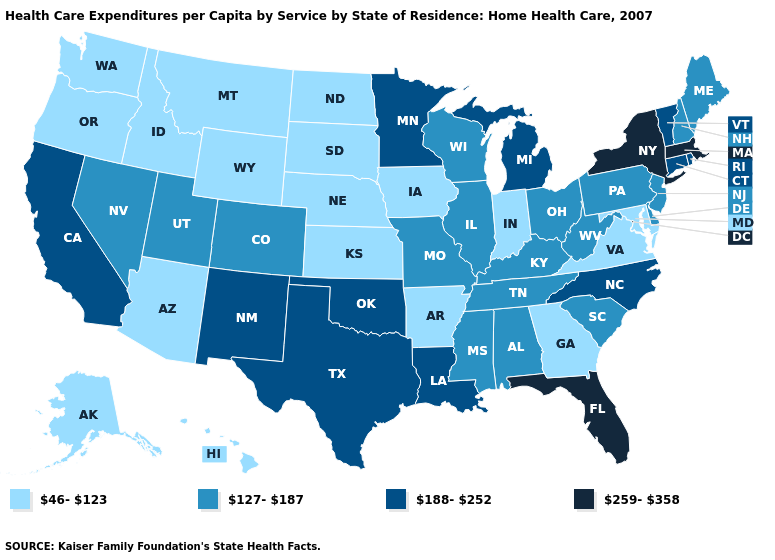Which states have the highest value in the USA?
Give a very brief answer. Florida, Massachusetts, New York. Does Louisiana have a higher value than West Virginia?
Answer briefly. Yes. How many symbols are there in the legend?
Concise answer only. 4. What is the lowest value in the Northeast?
Be succinct. 127-187. Is the legend a continuous bar?
Write a very short answer. No. What is the value of Illinois?
Quick response, please. 127-187. What is the value of Minnesota?
Keep it brief. 188-252. Does Kentucky have a lower value than Oklahoma?
Short answer required. Yes. Name the states that have a value in the range 46-123?
Answer briefly. Alaska, Arizona, Arkansas, Georgia, Hawaii, Idaho, Indiana, Iowa, Kansas, Maryland, Montana, Nebraska, North Dakota, Oregon, South Dakota, Virginia, Washington, Wyoming. What is the value of Virginia?
Be succinct. 46-123. What is the value of Maryland?
Be succinct. 46-123. What is the value of Pennsylvania?
Concise answer only. 127-187. What is the highest value in states that border Delaware?
Concise answer only. 127-187. Which states have the lowest value in the USA?
Concise answer only. Alaska, Arizona, Arkansas, Georgia, Hawaii, Idaho, Indiana, Iowa, Kansas, Maryland, Montana, Nebraska, North Dakota, Oregon, South Dakota, Virginia, Washington, Wyoming. Which states have the highest value in the USA?
Keep it brief. Florida, Massachusetts, New York. 